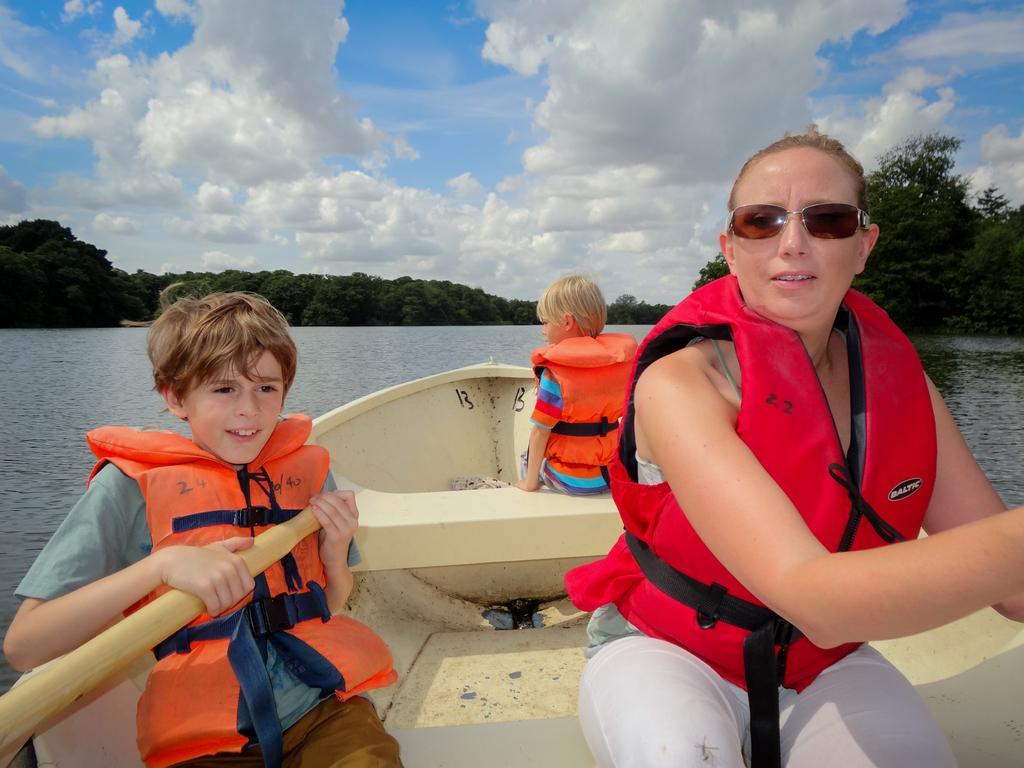How would you summarize this image in a sentence or two? In the center of the image we can see one boat on the water. In the boat, we can see three persons are sitting and they are wearing jackets. Among them, we can see one boy is holding a paddle and the other person is wearing sunglasses. In the background we can see the sky, clouds, trees, waters and a few people object. 